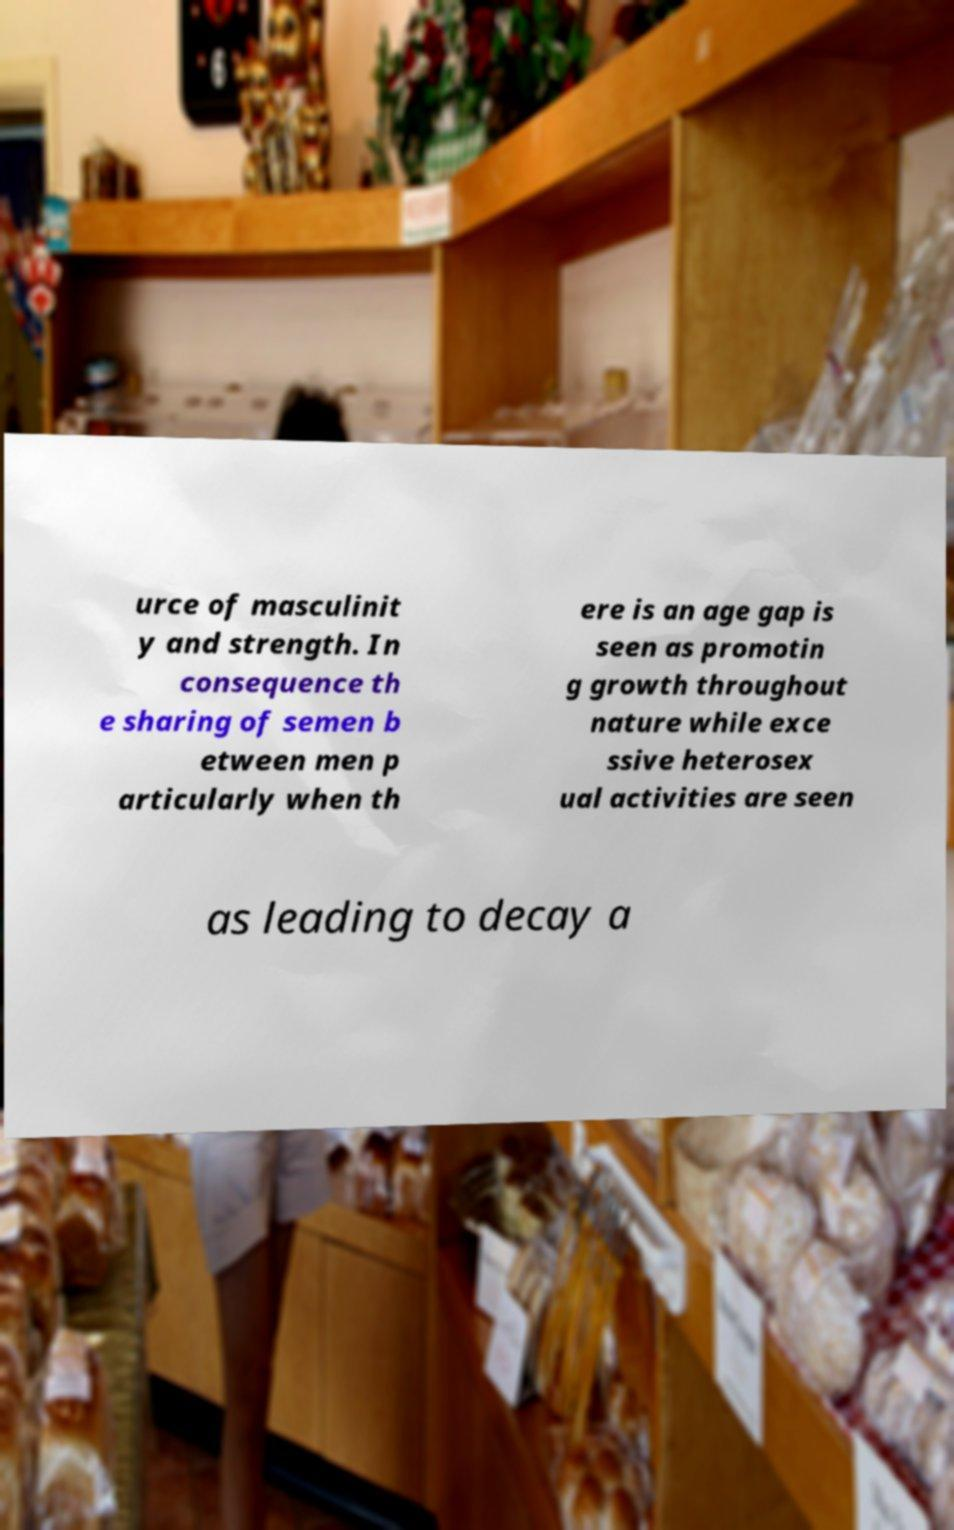I need the written content from this picture converted into text. Can you do that? urce of masculinit y and strength. In consequence th e sharing of semen b etween men p articularly when th ere is an age gap is seen as promotin g growth throughout nature while exce ssive heterosex ual activities are seen as leading to decay a 